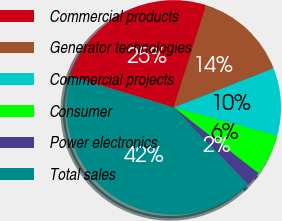Convert chart to OTSL. <chart><loc_0><loc_0><loc_500><loc_500><pie_chart><fcel>Commercial products<fcel>Generator technologies<fcel>Commercial projects<fcel>Consumer<fcel>Power electronics<fcel>Total sales<nl><fcel>25.23%<fcel>14.16%<fcel>10.2%<fcel>6.25%<fcel>2.29%<fcel>41.87%<nl></chart> 